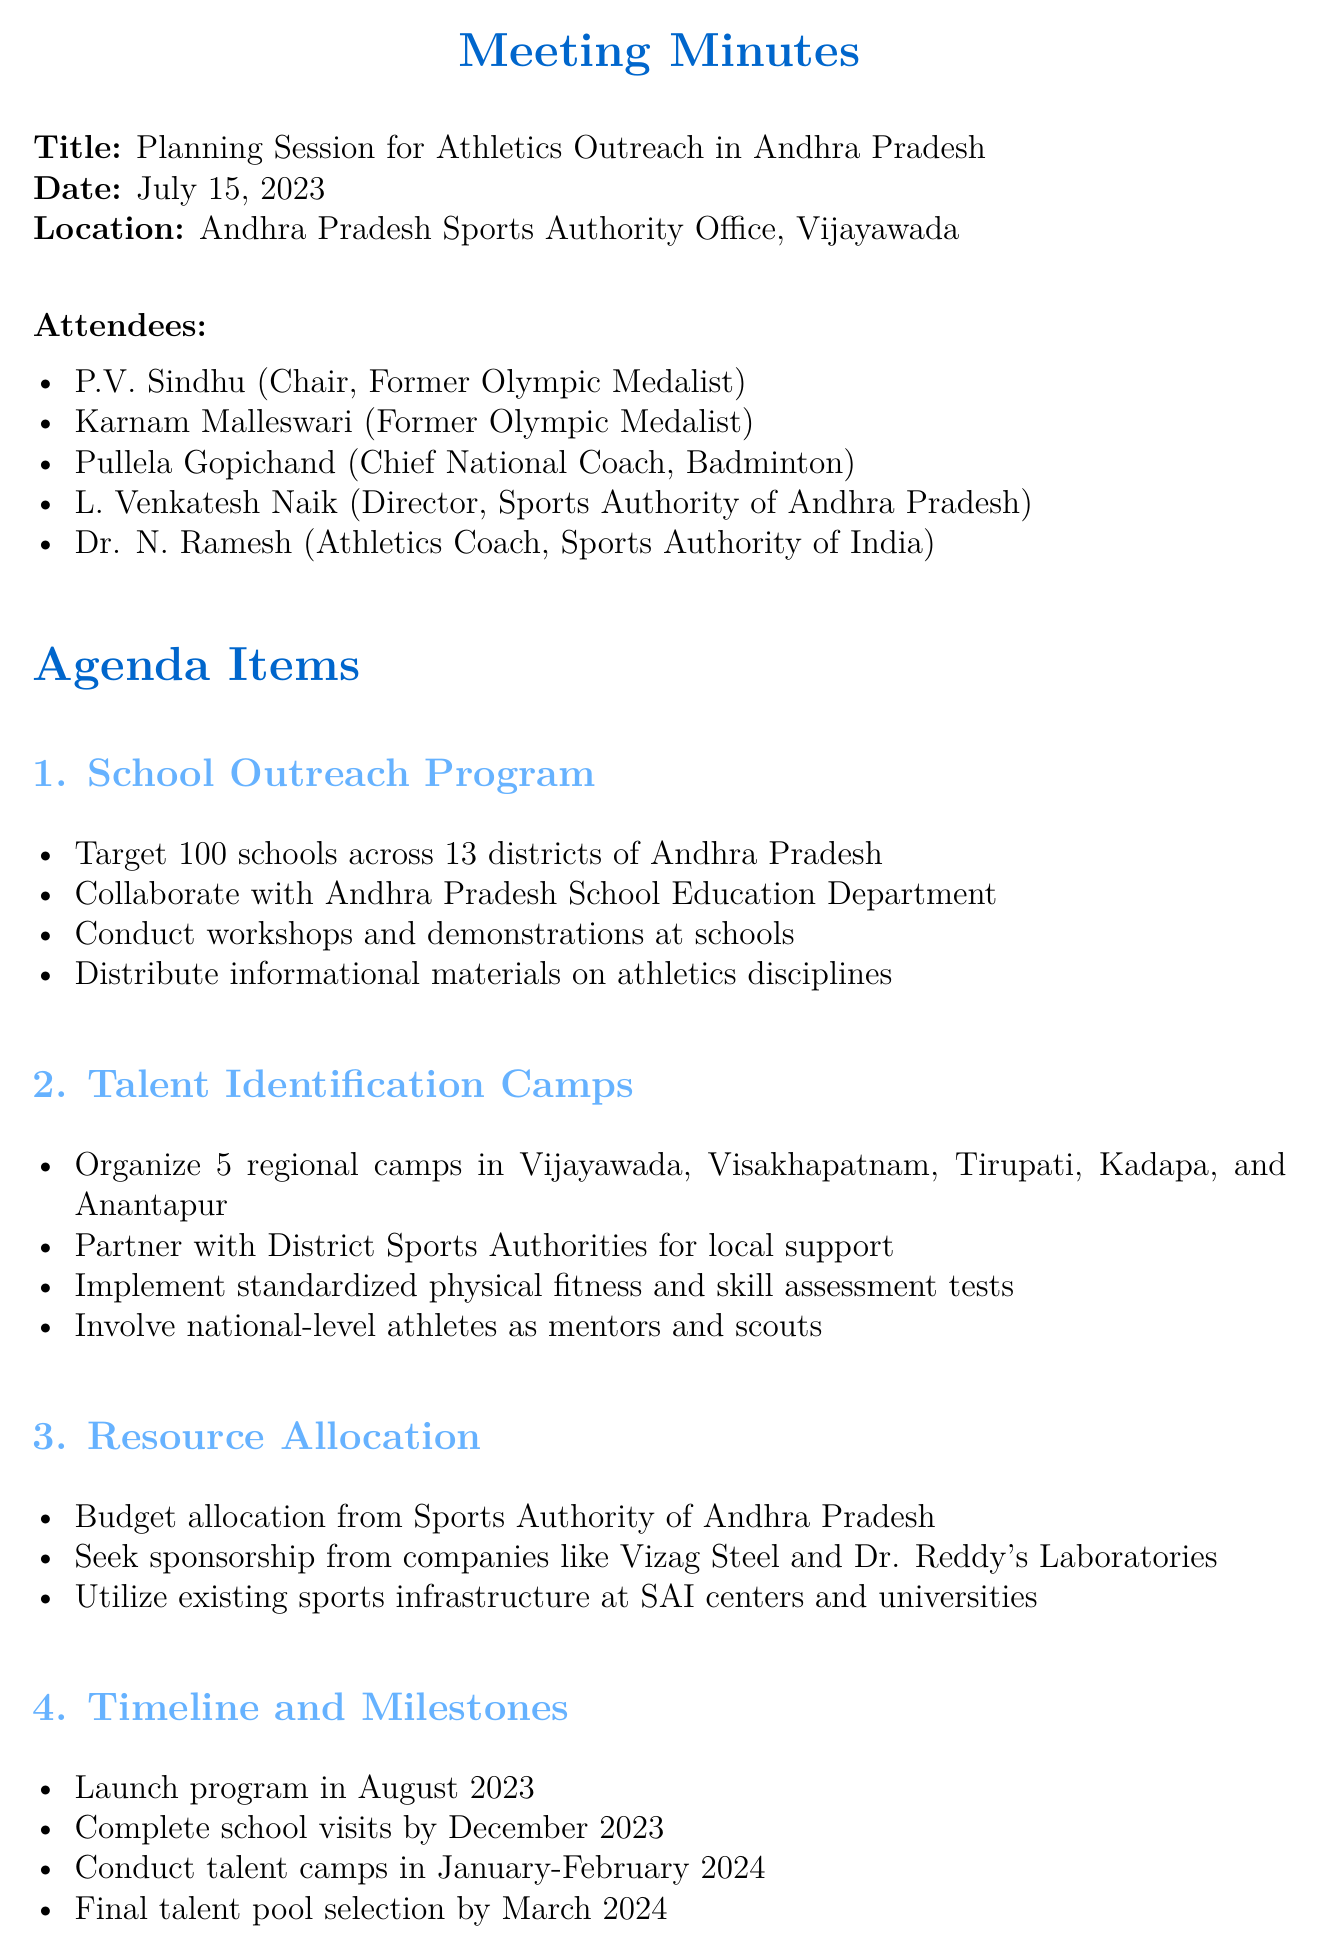What is the title of the meeting? The title of the meeting is presented at the beginning of the document.
Answer: Planning Session for Athletics Outreach in Andhra Pradesh Who chaired the meeting? The chair of the meeting is explicitly mentioned in the list of attendees.
Answer: P.V. Sindhu How many school visits are targeted in the outreach program? The number of targeted schools is stated under the School Outreach Program agenda item.
Answer: 100 schools What are the names of the cities where talent identification camps will be organized? The cities are listed in the Talent Identification Camps section of the document.
Answer: Vijayawada, Visakhapatnam, Tirupati, Kadapa, Anantapur When is the program scheduled to launch? The launch date is included in the Timeline and Milestones section.
Answer: August 2023 What is one of the mentioned sponsors in the document? Sponsorship sources are outlined in the Resource Allocation section.
Answer: Vizag Steel Which department will collaborate for the School Outreach Program? The collaborating department is mentioned in the details of the School Outreach Program.
Answer: Andhra Pradesh School Education Department What will be established for identified talents according to the follow-up actions? The follow-up actions detail will describe what will be created for talents.
Answer: Training programs 